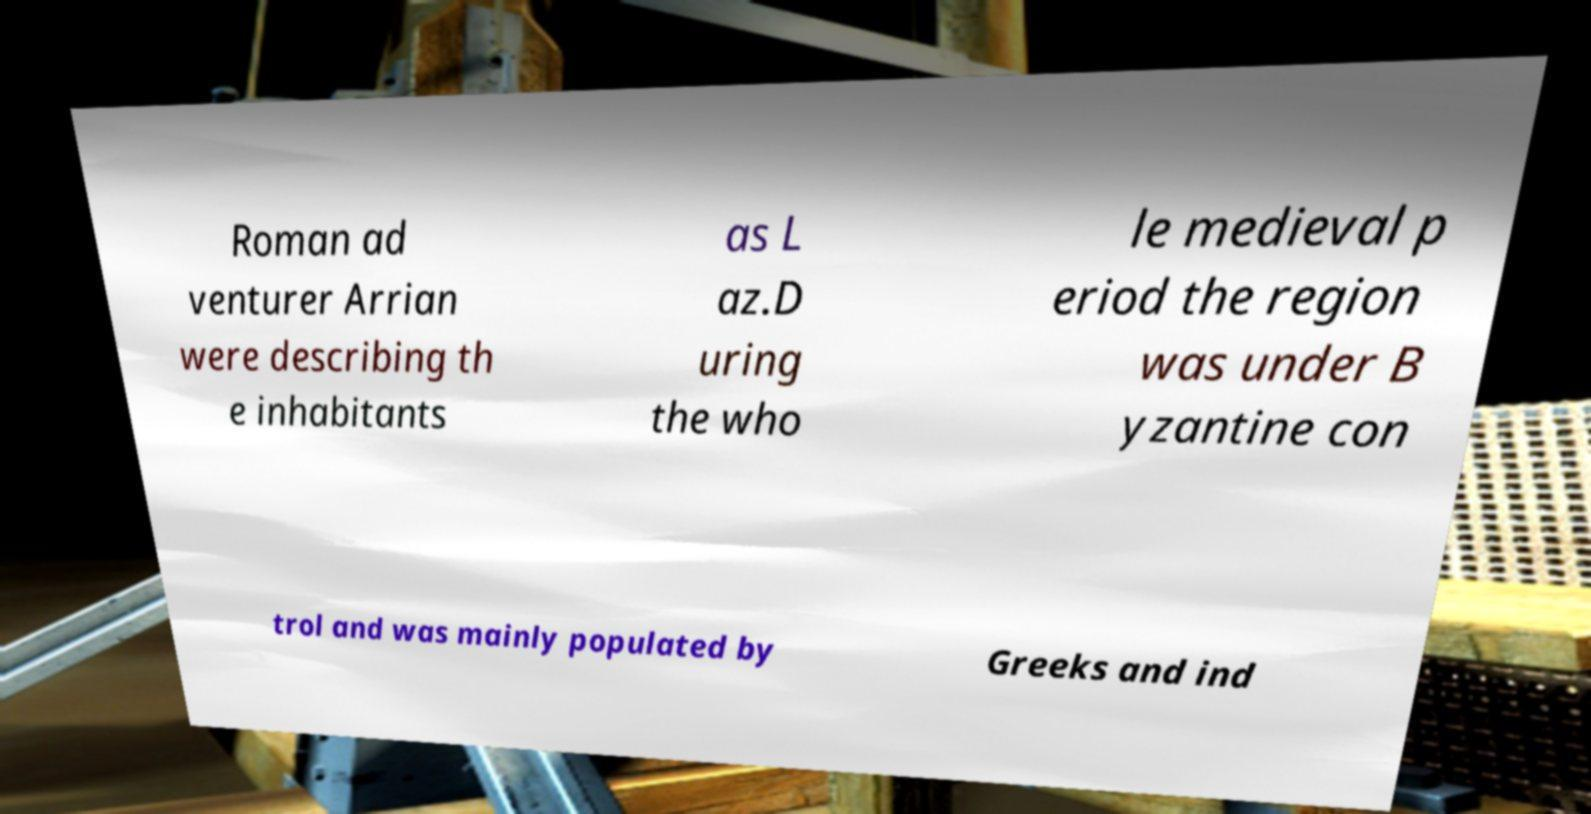I need the written content from this picture converted into text. Can you do that? Roman ad venturer Arrian were describing th e inhabitants as L az.D uring the who le medieval p eriod the region was under B yzantine con trol and was mainly populated by Greeks and ind 